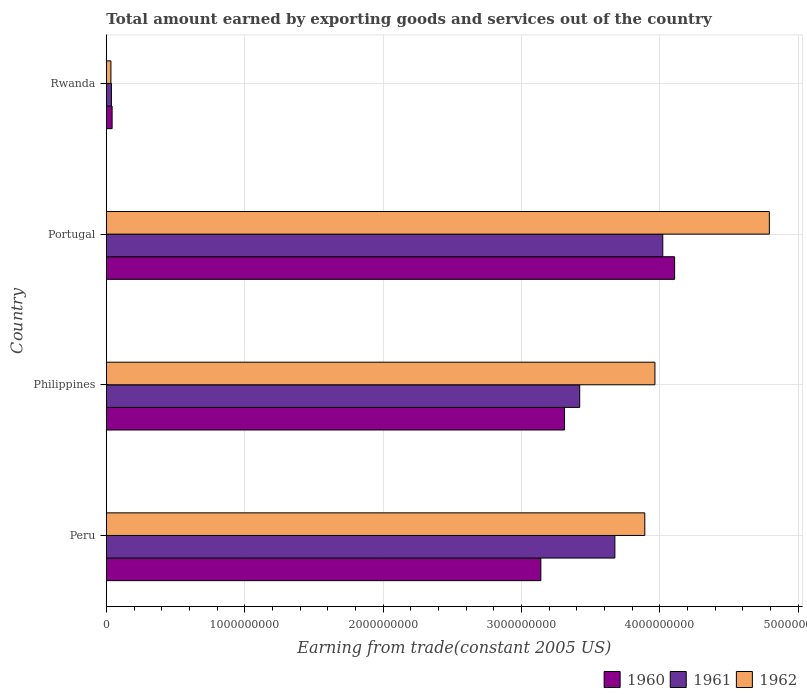Are the number of bars per tick equal to the number of legend labels?
Keep it short and to the point. Yes. Are the number of bars on each tick of the Y-axis equal?
Your answer should be very brief. Yes. In how many cases, is the number of bars for a given country not equal to the number of legend labels?
Ensure brevity in your answer.  0. What is the total amount earned by exporting goods and services in 1960 in Peru?
Offer a very short reply. 3.14e+09. Across all countries, what is the maximum total amount earned by exporting goods and services in 1960?
Your answer should be very brief. 4.11e+09. Across all countries, what is the minimum total amount earned by exporting goods and services in 1960?
Your answer should be compact. 4.18e+07. In which country was the total amount earned by exporting goods and services in 1960 minimum?
Offer a very short reply. Rwanda. What is the total total amount earned by exporting goods and services in 1960 in the graph?
Keep it short and to the point. 1.06e+1. What is the difference between the total amount earned by exporting goods and services in 1961 in Peru and that in Portugal?
Give a very brief answer. -3.46e+08. What is the difference between the total amount earned by exporting goods and services in 1961 in Philippines and the total amount earned by exporting goods and services in 1960 in Portugal?
Give a very brief answer. -6.86e+08. What is the average total amount earned by exporting goods and services in 1962 per country?
Your answer should be very brief. 3.17e+09. What is the difference between the total amount earned by exporting goods and services in 1962 and total amount earned by exporting goods and services in 1960 in Peru?
Provide a succinct answer. 7.51e+08. What is the ratio of the total amount earned by exporting goods and services in 1960 in Peru to that in Rwanda?
Keep it short and to the point. 75.2. Is the difference between the total amount earned by exporting goods and services in 1962 in Peru and Philippines greater than the difference between the total amount earned by exporting goods and services in 1960 in Peru and Philippines?
Provide a short and direct response. Yes. What is the difference between the highest and the second highest total amount earned by exporting goods and services in 1961?
Your answer should be very brief. 3.46e+08. What is the difference between the highest and the lowest total amount earned by exporting goods and services in 1961?
Offer a terse response. 3.98e+09. Is the sum of the total amount earned by exporting goods and services in 1960 in Peru and Philippines greater than the maximum total amount earned by exporting goods and services in 1961 across all countries?
Your answer should be very brief. Yes. What does the 3rd bar from the bottom in Portugal represents?
Ensure brevity in your answer.  1962. Is it the case that in every country, the sum of the total amount earned by exporting goods and services in 1960 and total amount earned by exporting goods and services in 1962 is greater than the total amount earned by exporting goods and services in 1961?
Make the answer very short. Yes. How many countries are there in the graph?
Your response must be concise. 4. What is the difference between two consecutive major ticks on the X-axis?
Your response must be concise. 1.00e+09. Does the graph contain grids?
Your answer should be very brief. Yes. How many legend labels are there?
Offer a very short reply. 3. What is the title of the graph?
Offer a very short reply. Total amount earned by exporting goods and services out of the country. Does "1977" appear as one of the legend labels in the graph?
Make the answer very short. No. What is the label or title of the X-axis?
Provide a succinct answer. Earning from trade(constant 2005 US). What is the Earning from trade(constant 2005 US) in 1960 in Peru?
Give a very brief answer. 3.14e+09. What is the Earning from trade(constant 2005 US) of 1961 in Peru?
Ensure brevity in your answer.  3.68e+09. What is the Earning from trade(constant 2005 US) of 1962 in Peru?
Provide a short and direct response. 3.89e+09. What is the Earning from trade(constant 2005 US) in 1960 in Philippines?
Offer a very short reply. 3.31e+09. What is the Earning from trade(constant 2005 US) of 1961 in Philippines?
Your answer should be very brief. 3.42e+09. What is the Earning from trade(constant 2005 US) of 1962 in Philippines?
Your response must be concise. 3.97e+09. What is the Earning from trade(constant 2005 US) in 1960 in Portugal?
Your answer should be compact. 4.11e+09. What is the Earning from trade(constant 2005 US) of 1961 in Portugal?
Provide a succinct answer. 4.02e+09. What is the Earning from trade(constant 2005 US) in 1962 in Portugal?
Give a very brief answer. 4.79e+09. What is the Earning from trade(constant 2005 US) in 1960 in Rwanda?
Provide a succinct answer. 4.18e+07. What is the Earning from trade(constant 2005 US) in 1961 in Rwanda?
Keep it short and to the point. 3.69e+07. What is the Earning from trade(constant 2005 US) of 1962 in Rwanda?
Provide a short and direct response. 3.32e+07. Across all countries, what is the maximum Earning from trade(constant 2005 US) of 1960?
Keep it short and to the point. 4.11e+09. Across all countries, what is the maximum Earning from trade(constant 2005 US) of 1961?
Make the answer very short. 4.02e+09. Across all countries, what is the maximum Earning from trade(constant 2005 US) in 1962?
Provide a short and direct response. 4.79e+09. Across all countries, what is the minimum Earning from trade(constant 2005 US) in 1960?
Your response must be concise. 4.18e+07. Across all countries, what is the minimum Earning from trade(constant 2005 US) in 1961?
Ensure brevity in your answer.  3.69e+07. Across all countries, what is the minimum Earning from trade(constant 2005 US) of 1962?
Make the answer very short. 3.32e+07. What is the total Earning from trade(constant 2005 US) of 1960 in the graph?
Offer a terse response. 1.06e+1. What is the total Earning from trade(constant 2005 US) of 1961 in the graph?
Make the answer very short. 1.12e+1. What is the total Earning from trade(constant 2005 US) of 1962 in the graph?
Provide a short and direct response. 1.27e+1. What is the difference between the Earning from trade(constant 2005 US) of 1960 in Peru and that in Philippines?
Your answer should be very brief. -1.71e+08. What is the difference between the Earning from trade(constant 2005 US) of 1961 in Peru and that in Philippines?
Offer a very short reply. 2.54e+08. What is the difference between the Earning from trade(constant 2005 US) of 1962 in Peru and that in Philippines?
Provide a succinct answer. -7.32e+07. What is the difference between the Earning from trade(constant 2005 US) of 1960 in Peru and that in Portugal?
Make the answer very short. -9.67e+08. What is the difference between the Earning from trade(constant 2005 US) in 1961 in Peru and that in Portugal?
Your response must be concise. -3.46e+08. What is the difference between the Earning from trade(constant 2005 US) in 1962 in Peru and that in Portugal?
Provide a succinct answer. -9.00e+08. What is the difference between the Earning from trade(constant 2005 US) of 1960 in Peru and that in Rwanda?
Offer a very short reply. 3.10e+09. What is the difference between the Earning from trade(constant 2005 US) in 1961 in Peru and that in Rwanda?
Your answer should be compact. 3.64e+09. What is the difference between the Earning from trade(constant 2005 US) of 1962 in Peru and that in Rwanda?
Offer a very short reply. 3.86e+09. What is the difference between the Earning from trade(constant 2005 US) of 1960 in Philippines and that in Portugal?
Provide a succinct answer. -7.96e+08. What is the difference between the Earning from trade(constant 2005 US) of 1961 in Philippines and that in Portugal?
Ensure brevity in your answer.  -6.01e+08. What is the difference between the Earning from trade(constant 2005 US) of 1962 in Philippines and that in Portugal?
Offer a terse response. -8.27e+08. What is the difference between the Earning from trade(constant 2005 US) in 1960 in Philippines and that in Rwanda?
Provide a succinct answer. 3.27e+09. What is the difference between the Earning from trade(constant 2005 US) in 1961 in Philippines and that in Rwanda?
Give a very brief answer. 3.38e+09. What is the difference between the Earning from trade(constant 2005 US) of 1962 in Philippines and that in Rwanda?
Your answer should be very brief. 3.93e+09. What is the difference between the Earning from trade(constant 2005 US) in 1960 in Portugal and that in Rwanda?
Provide a short and direct response. 4.07e+09. What is the difference between the Earning from trade(constant 2005 US) of 1961 in Portugal and that in Rwanda?
Provide a succinct answer. 3.98e+09. What is the difference between the Earning from trade(constant 2005 US) of 1962 in Portugal and that in Rwanda?
Keep it short and to the point. 4.76e+09. What is the difference between the Earning from trade(constant 2005 US) of 1960 in Peru and the Earning from trade(constant 2005 US) of 1961 in Philippines?
Provide a short and direct response. -2.81e+08. What is the difference between the Earning from trade(constant 2005 US) of 1960 in Peru and the Earning from trade(constant 2005 US) of 1962 in Philippines?
Ensure brevity in your answer.  -8.24e+08. What is the difference between the Earning from trade(constant 2005 US) of 1961 in Peru and the Earning from trade(constant 2005 US) of 1962 in Philippines?
Offer a terse response. -2.89e+08. What is the difference between the Earning from trade(constant 2005 US) in 1960 in Peru and the Earning from trade(constant 2005 US) in 1961 in Portugal?
Provide a short and direct response. -8.81e+08. What is the difference between the Earning from trade(constant 2005 US) in 1960 in Peru and the Earning from trade(constant 2005 US) in 1962 in Portugal?
Offer a terse response. -1.65e+09. What is the difference between the Earning from trade(constant 2005 US) of 1961 in Peru and the Earning from trade(constant 2005 US) of 1962 in Portugal?
Offer a very short reply. -1.12e+09. What is the difference between the Earning from trade(constant 2005 US) of 1960 in Peru and the Earning from trade(constant 2005 US) of 1961 in Rwanda?
Provide a short and direct response. 3.10e+09. What is the difference between the Earning from trade(constant 2005 US) of 1960 in Peru and the Earning from trade(constant 2005 US) of 1962 in Rwanda?
Your answer should be compact. 3.11e+09. What is the difference between the Earning from trade(constant 2005 US) in 1961 in Peru and the Earning from trade(constant 2005 US) in 1962 in Rwanda?
Ensure brevity in your answer.  3.64e+09. What is the difference between the Earning from trade(constant 2005 US) in 1960 in Philippines and the Earning from trade(constant 2005 US) in 1961 in Portugal?
Your response must be concise. -7.10e+08. What is the difference between the Earning from trade(constant 2005 US) of 1960 in Philippines and the Earning from trade(constant 2005 US) of 1962 in Portugal?
Provide a short and direct response. -1.48e+09. What is the difference between the Earning from trade(constant 2005 US) in 1961 in Philippines and the Earning from trade(constant 2005 US) in 1962 in Portugal?
Keep it short and to the point. -1.37e+09. What is the difference between the Earning from trade(constant 2005 US) of 1960 in Philippines and the Earning from trade(constant 2005 US) of 1961 in Rwanda?
Give a very brief answer. 3.27e+09. What is the difference between the Earning from trade(constant 2005 US) in 1960 in Philippines and the Earning from trade(constant 2005 US) in 1962 in Rwanda?
Provide a short and direct response. 3.28e+09. What is the difference between the Earning from trade(constant 2005 US) of 1961 in Philippines and the Earning from trade(constant 2005 US) of 1962 in Rwanda?
Your answer should be compact. 3.39e+09. What is the difference between the Earning from trade(constant 2005 US) of 1960 in Portugal and the Earning from trade(constant 2005 US) of 1961 in Rwanda?
Your answer should be very brief. 4.07e+09. What is the difference between the Earning from trade(constant 2005 US) in 1960 in Portugal and the Earning from trade(constant 2005 US) in 1962 in Rwanda?
Offer a terse response. 4.07e+09. What is the difference between the Earning from trade(constant 2005 US) of 1961 in Portugal and the Earning from trade(constant 2005 US) of 1962 in Rwanda?
Offer a very short reply. 3.99e+09. What is the average Earning from trade(constant 2005 US) in 1960 per country?
Offer a very short reply. 2.65e+09. What is the average Earning from trade(constant 2005 US) of 1961 per country?
Give a very brief answer. 2.79e+09. What is the average Earning from trade(constant 2005 US) in 1962 per country?
Keep it short and to the point. 3.17e+09. What is the difference between the Earning from trade(constant 2005 US) in 1960 and Earning from trade(constant 2005 US) in 1961 in Peru?
Your answer should be very brief. -5.35e+08. What is the difference between the Earning from trade(constant 2005 US) in 1960 and Earning from trade(constant 2005 US) in 1962 in Peru?
Provide a succinct answer. -7.51e+08. What is the difference between the Earning from trade(constant 2005 US) in 1961 and Earning from trade(constant 2005 US) in 1962 in Peru?
Offer a terse response. -2.16e+08. What is the difference between the Earning from trade(constant 2005 US) of 1960 and Earning from trade(constant 2005 US) of 1961 in Philippines?
Provide a short and direct response. -1.10e+08. What is the difference between the Earning from trade(constant 2005 US) of 1960 and Earning from trade(constant 2005 US) of 1962 in Philippines?
Your answer should be compact. -6.53e+08. What is the difference between the Earning from trade(constant 2005 US) in 1961 and Earning from trade(constant 2005 US) in 1962 in Philippines?
Keep it short and to the point. -5.44e+08. What is the difference between the Earning from trade(constant 2005 US) of 1960 and Earning from trade(constant 2005 US) of 1961 in Portugal?
Keep it short and to the point. 8.56e+07. What is the difference between the Earning from trade(constant 2005 US) in 1960 and Earning from trade(constant 2005 US) in 1962 in Portugal?
Ensure brevity in your answer.  -6.85e+08. What is the difference between the Earning from trade(constant 2005 US) of 1961 and Earning from trade(constant 2005 US) of 1962 in Portugal?
Provide a succinct answer. -7.70e+08. What is the difference between the Earning from trade(constant 2005 US) of 1960 and Earning from trade(constant 2005 US) of 1961 in Rwanda?
Give a very brief answer. 4.89e+06. What is the difference between the Earning from trade(constant 2005 US) of 1960 and Earning from trade(constant 2005 US) of 1962 in Rwanda?
Your response must be concise. 8.56e+06. What is the difference between the Earning from trade(constant 2005 US) in 1961 and Earning from trade(constant 2005 US) in 1962 in Rwanda?
Your answer should be very brief. 3.68e+06. What is the ratio of the Earning from trade(constant 2005 US) in 1960 in Peru to that in Philippines?
Offer a terse response. 0.95. What is the ratio of the Earning from trade(constant 2005 US) of 1961 in Peru to that in Philippines?
Offer a very short reply. 1.07. What is the ratio of the Earning from trade(constant 2005 US) in 1962 in Peru to that in Philippines?
Your response must be concise. 0.98. What is the ratio of the Earning from trade(constant 2005 US) of 1960 in Peru to that in Portugal?
Keep it short and to the point. 0.76. What is the ratio of the Earning from trade(constant 2005 US) of 1961 in Peru to that in Portugal?
Provide a short and direct response. 0.91. What is the ratio of the Earning from trade(constant 2005 US) of 1962 in Peru to that in Portugal?
Your answer should be very brief. 0.81. What is the ratio of the Earning from trade(constant 2005 US) of 1960 in Peru to that in Rwanda?
Your answer should be very brief. 75.2. What is the ratio of the Earning from trade(constant 2005 US) of 1961 in Peru to that in Rwanda?
Offer a very short reply. 99.66. What is the ratio of the Earning from trade(constant 2005 US) in 1962 in Peru to that in Rwanda?
Make the answer very short. 117.21. What is the ratio of the Earning from trade(constant 2005 US) of 1960 in Philippines to that in Portugal?
Provide a succinct answer. 0.81. What is the ratio of the Earning from trade(constant 2005 US) in 1961 in Philippines to that in Portugal?
Provide a short and direct response. 0.85. What is the ratio of the Earning from trade(constant 2005 US) in 1962 in Philippines to that in Portugal?
Ensure brevity in your answer.  0.83. What is the ratio of the Earning from trade(constant 2005 US) in 1960 in Philippines to that in Rwanda?
Your answer should be very brief. 79.29. What is the ratio of the Earning from trade(constant 2005 US) in 1961 in Philippines to that in Rwanda?
Keep it short and to the point. 92.77. What is the ratio of the Earning from trade(constant 2005 US) in 1962 in Philippines to that in Rwanda?
Give a very brief answer. 119.41. What is the ratio of the Earning from trade(constant 2005 US) in 1960 in Portugal to that in Rwanda?
Your answer should be compact. 98.35. What is the ratio of the Earning from trade(constant 2005 US) of 1961 in Portugal to that in Rwanda?
Provide a succinct answer. 109.05. What is the ratio of the Earning from trade(constant 2005 US) of 1962 in Portugal to that in Rwanda?
Make the answer very short. 144.32. What is the difference between the highest and the second highest Earning from trade(constant 2005 US) of 1960?
Provide a short and direct response. 7.96e+08. What is the difference between the highest and the second highest Earning from trade(constant 2005 US) in 1961?
Offer a terse response. 3.46e+08. What is the difference between the highest and the second highest Earning from trade(constant 2005 US) in 1962?
Offer a terse response. 8.27e+08. What is the difference between the highest and the lowest Earning from trade(constant 2005 US) of 1960?
Your answer should be compact. 4.07e+09. What is the difference between the highest and the lowest Earning from trade(constant 2005 US) of 1961?
Make the answer very short. 3.98e+09. What is the difference between the highest and the lowest Earning from trade(constant 2005 US) in 1962?
Provide a short and direct response. 4.76e+09. 